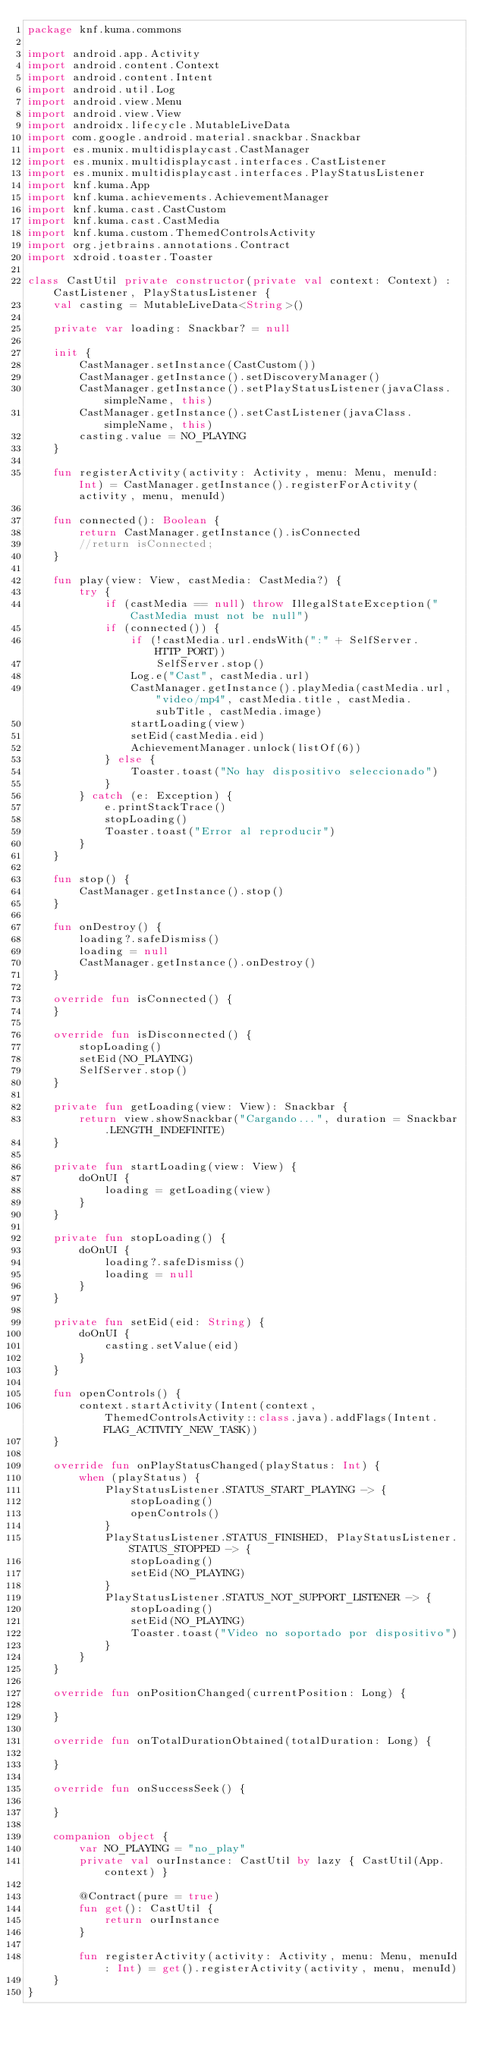<code> <loc_0><loc_0><loc_500><loc_500><_Kotlin_>package knf.kuma.commons

import android.app.Activity
import android.content.Context
import android.content.Intent
import android.util.Log
import android.view.Menu
import android.view.View
import androidx.lifecycle.MutableLiveData
import com.google.android.material.snackbar.Snackbar
import es.munix.multidisplaycast.CastManager
import es.munix.multidisplaycast.interfaces.CastListener
import es.munix.multidisplaycast.interfaces.PlayStatusListener
import knf.kuma.App
import knf.kuma.achievements.AchievementManager
import knf.kuma.cast.CastCustom
import knf.kuma.cast.CastMedia
import knf.kuma.custom.ThemedControlsActivity
import org.jetbrains.annotations.Contract
import xdroid.toaster.Toaster

class CastUtil private constructor(private val context: Context) : CastListener, PlayStatusListener {
    val casting = MutableLiveData<String>()

    private var loading: Snackbar? = null

    init {
        CastManager.setInstance(CastCustom())
        CastManager.getInstance().setDiscoveryManager()
        CastManager.getInstance().setPlayStatusListener(javaClass.simpleName, this)
        CastManager.getInstance().setCastListener(javaClass.simpleName, this)
        casting.value = NO_PLAYING
    }

    fun registerActivity(activity: Activity, menu: Menu, menuId: Int) = CastManager.getInstance().registerForActivity(activity, menu, menuId)

    fun connected(): Boolean {
        return CastManager.getInstance().isConnected
        //return isConnected;
    }

    fun play(view: View, castMedia: CastMedia?) {
        try {
            if (castMedia == null) throw IllegalStateException("CastMedia must not be null")
            if (connected()) {
                if (!castMedia.url.endsWith(":" + SelfServer.HTTP_PORT))
                    SelfServer.stop()
                Log.e("Cast", castMedia.url)
                CastManager.getInstance().playMedia(castMedia.url, "video/mp4", castMedia.title, castMedia.subTitle, castMedia.image)
                startLoading(view)
                setEid(castMedia.eid)
                AchievementManager.unlock(listOf(6))
            } else {
                Toaster.toast("No hay dispositivo seleccionado")
            }
        } catch (e: Exception) {
            e.printStackTrace()
            stopLoading()
            Toaster.toast("Error al reproducir")
        }
    }

    fun stop() {
        CastManager.getInstance().stop()
    }

    fun onDestroy() {
        loading?.safeDismiss()
        loading = null
        CastManager.getInstance().onDestroy()
    }

    override fun isConnected() {
    }

    override fun isDisconnected() {
        stopLoading()
        setEid(NO_PLAYING)
        SelfServer.stop()
    }

    private fun getLoading(view: View): Snackbar {
        return view.showSnackbar("Cargando...", duration = Snackbar.LENGTH_INDEFINITE)
    }

    private fun startLoading(view: View) {
        doOnUI {
            loading = getLoading(view)
        }
    }

    private fun stopLoading() {
        doOnUI {
            loading?.safeDismiss()
            loading = null
        }
    }

    private fun setEid(eid: String) {
        doOnUI {
            casting.setValue(eid)
        }
    }

    fun openControls() {
        context.startActivity(Intent(context, ThemedControlsActivity::class.java).addFlags(Intent.FLAG_ACTIVITY_NEW_TASK))
    }

    override fun onPlayStatusChanged(playStatus: Int) {
        when (playStatus) {
            PlayStatusListener.STATUS_START_PLAYING -> {
                stopLoading()
                openControls()
            }
            PlayStatusListener.STATUS_FINISHED, PlayStatusListener.STATUS_STOPPED -> {
                stopLoading()
                setEid(NO_PLAYING)
            }
            PlayStatusListener.STATUS_NOT_SUPPORT_LISTENER -> {
                stopLoading()
                setEid(NO_PLAYING)
                Toaster.toast("Video no soportado por dispositivo")
            }
        }
    }

    override fun onPositionChanged(currentPosition: Long) {

    }

    override fun onTotalDurationObtained(totalDuration: Long) {

    }

    override fun onSuccessSeek() {

    }

    companion object {
        var NO_PLAYING = "no_play"
        private val ourInstance: CastUtil by lazy { CastUtil(App.context) }

        @Contract(pure = true)
        fun get(): CastUtil {
            return ourInstance
        }

        fun registerActivity(activity: Activity, menu: Menu, menuId: Int) = get().registerActivity(activity, menu, menuId)
    }
}
</code> 